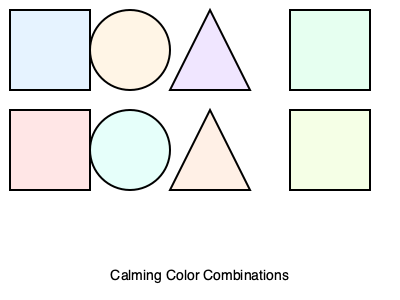Which pair of shapes in the image represents the most soothing color combination for someone who easily feels anxious? To determine the most soothing color combination for someone who easily feels anxious, we need to consider the psychological effects of colors:

1. Blue (light blue rectangle): Associated with calmness, serenity, and stability.
2. Beige (beige circle): Neutral, warm, and comforting.
3. Lavender (lavender triangle): Relaxing and soothing.
4. Mint green (mint green rectangle): Refreshing and calming.
5. Light pink (light pink rectangle): Gentle and nurturing.
6. Light teal (light teal circle): Peaceful and tranquil.
7. Peach (peach triangle): Warm and comforting.
8. Light yellow-green (light yellow-green rectangle): Fresh and calming.

For someone who easily feels anxious, the most soothing combination would be colors that promote relaxation and stability. The light blue rectangle and the beige circle offer the best combination:

- Light blue promotes calmness and stability, which can help reduce anxiety.
- Beige is a neutral, warm color that can provide comfort without being overstimulating.

This combination creates a balanced, serene atmosphere that is likely to be the most soothing for someone who gets easily scared or anxious.
Answer: Light blue rectangle and beige circle 